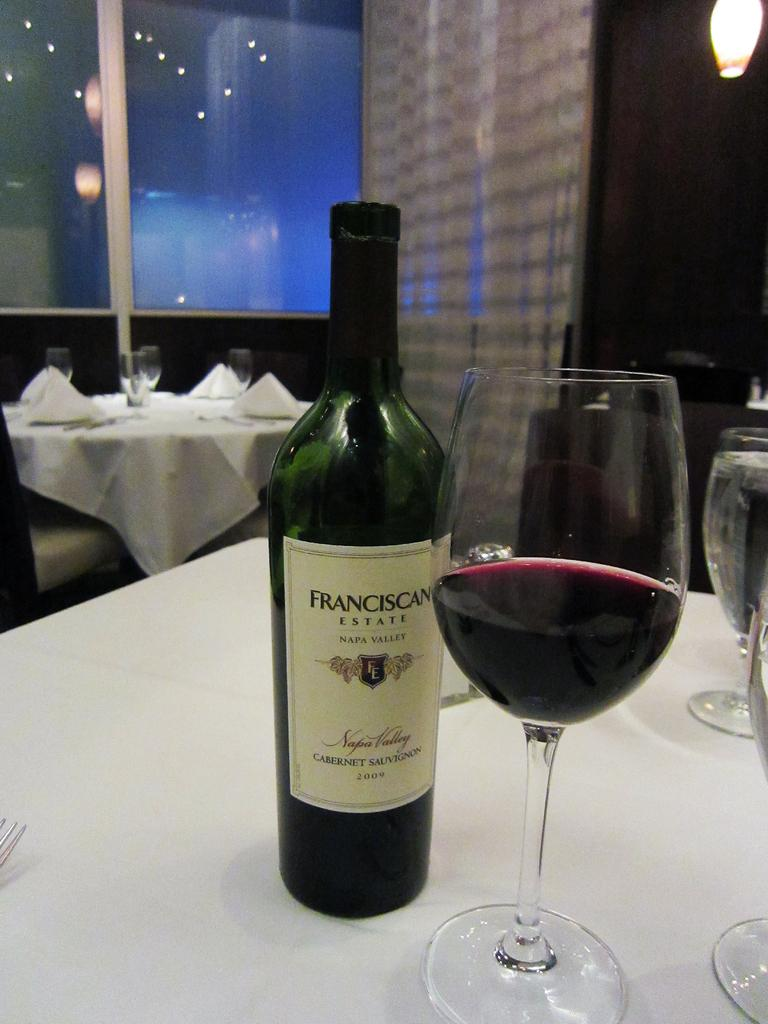<image>
Create a compact narrative representing the image presented. A Frankciscan wine bottle is present next to a wine glass of red wine 